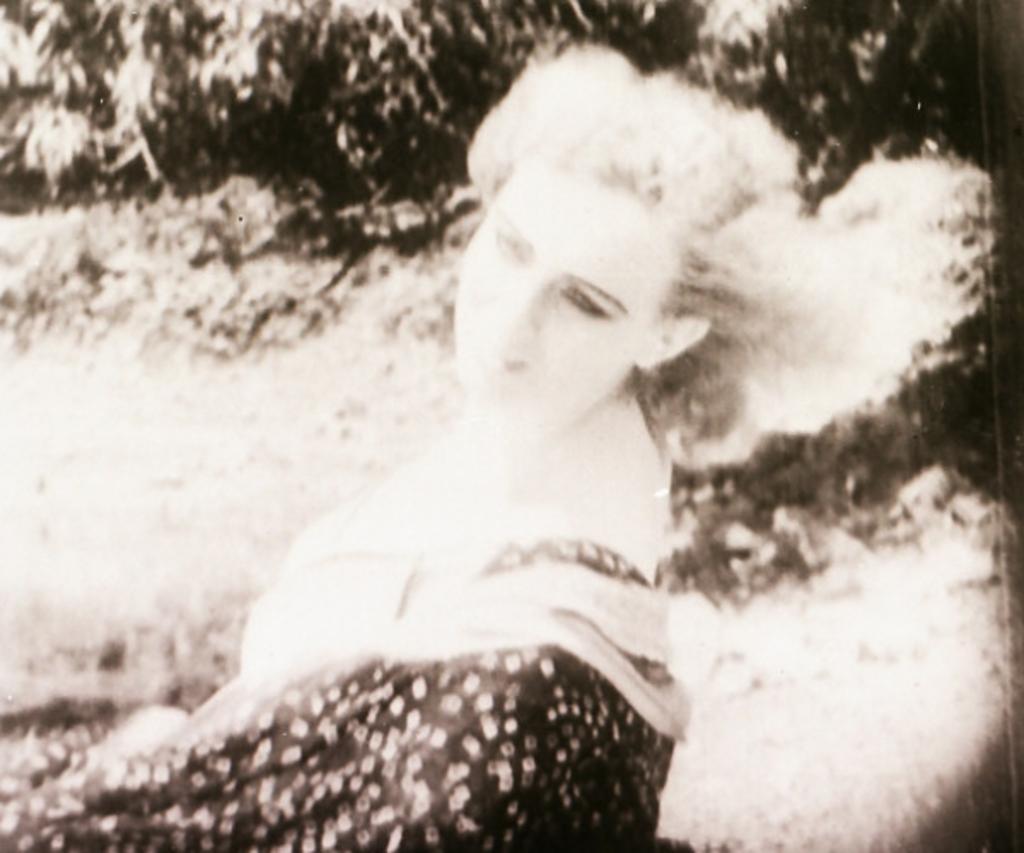Can you describe this image briefly? It is a black and white picture. Here we can see a woman. Background we can see trees and plants. 